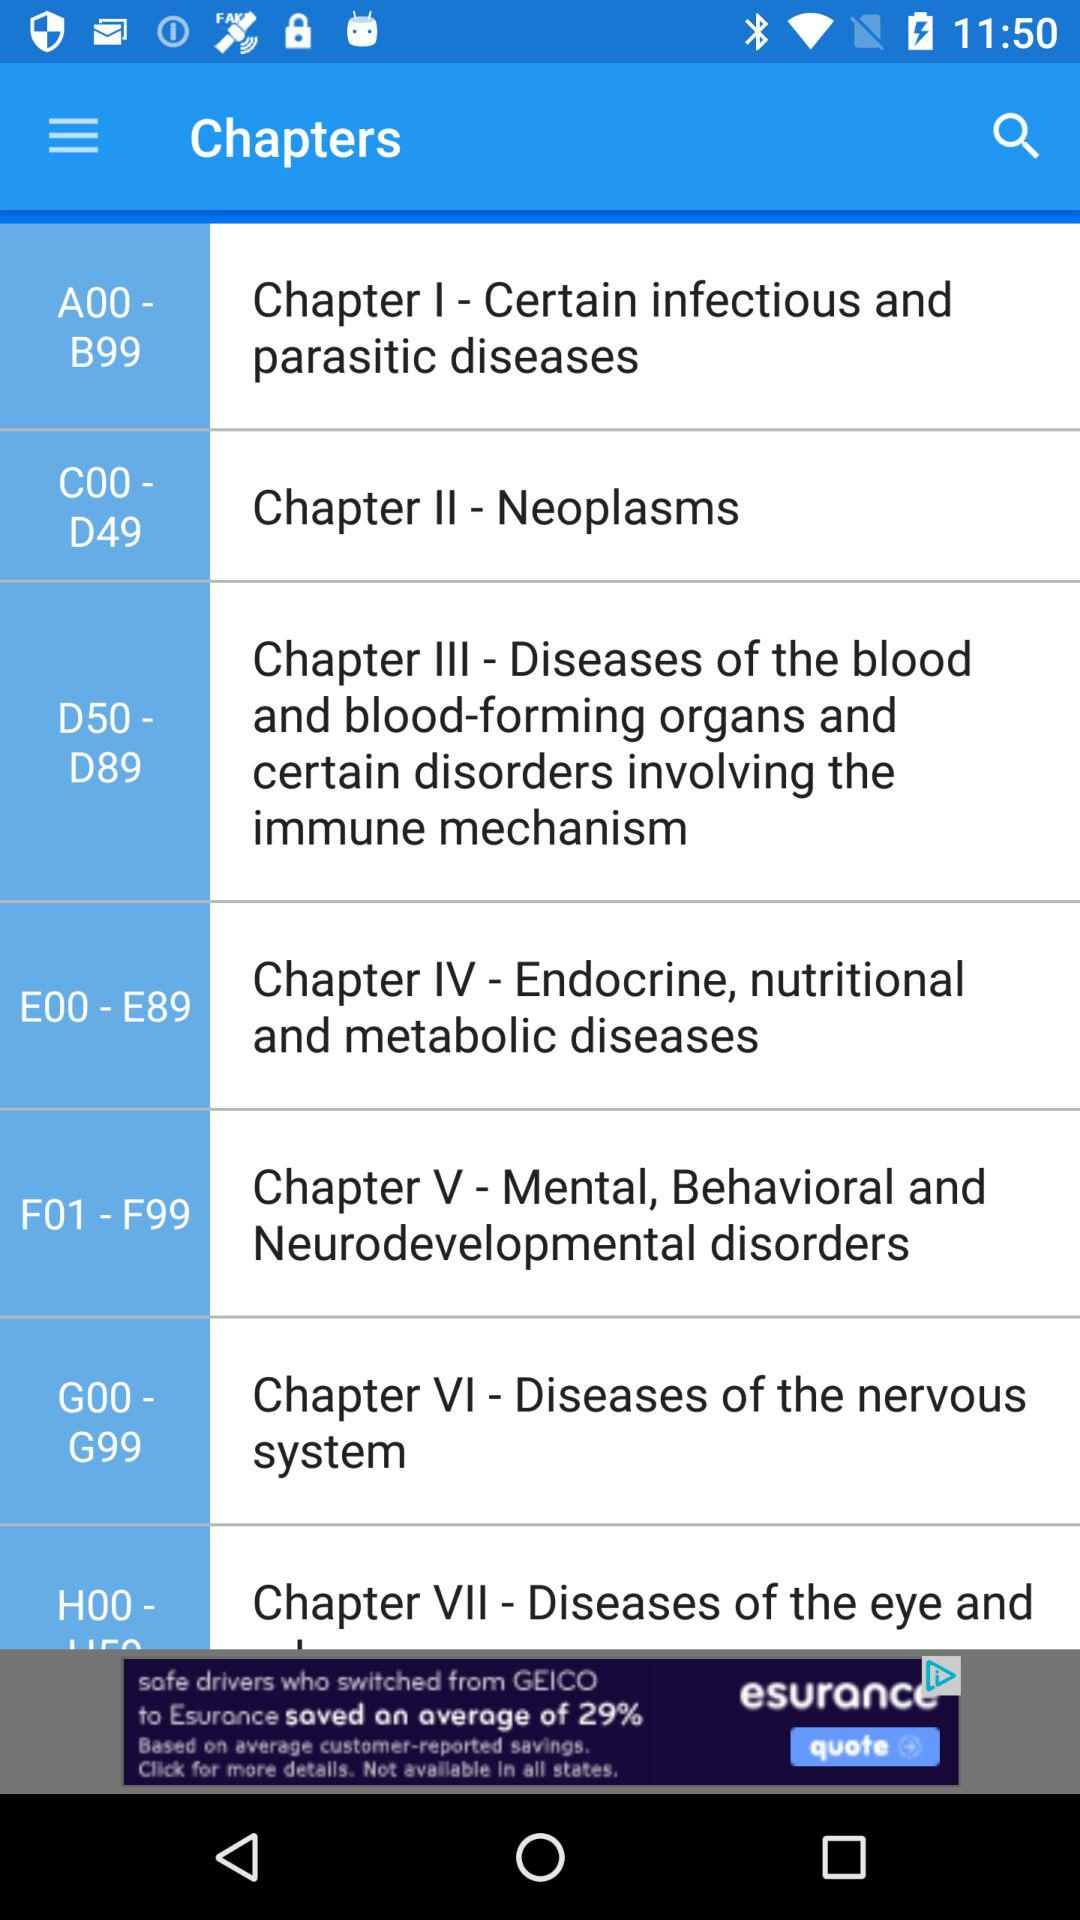How many chapters are in the first 3 sections?
Answer the question using a single word or phrase. 3 